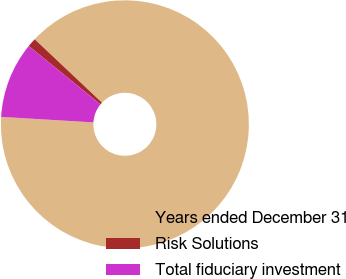Convert chart to OTSL. <chart><loc_0><loc_0><loc_500><loc_500><pie_chart><fcel>Years ended December 31<fcel>Risk Solutions<fcel>Total fiduciary investment<nl><fcel>88.93%<fcel>1.15%<fcel>9.93%<nl></chart> 